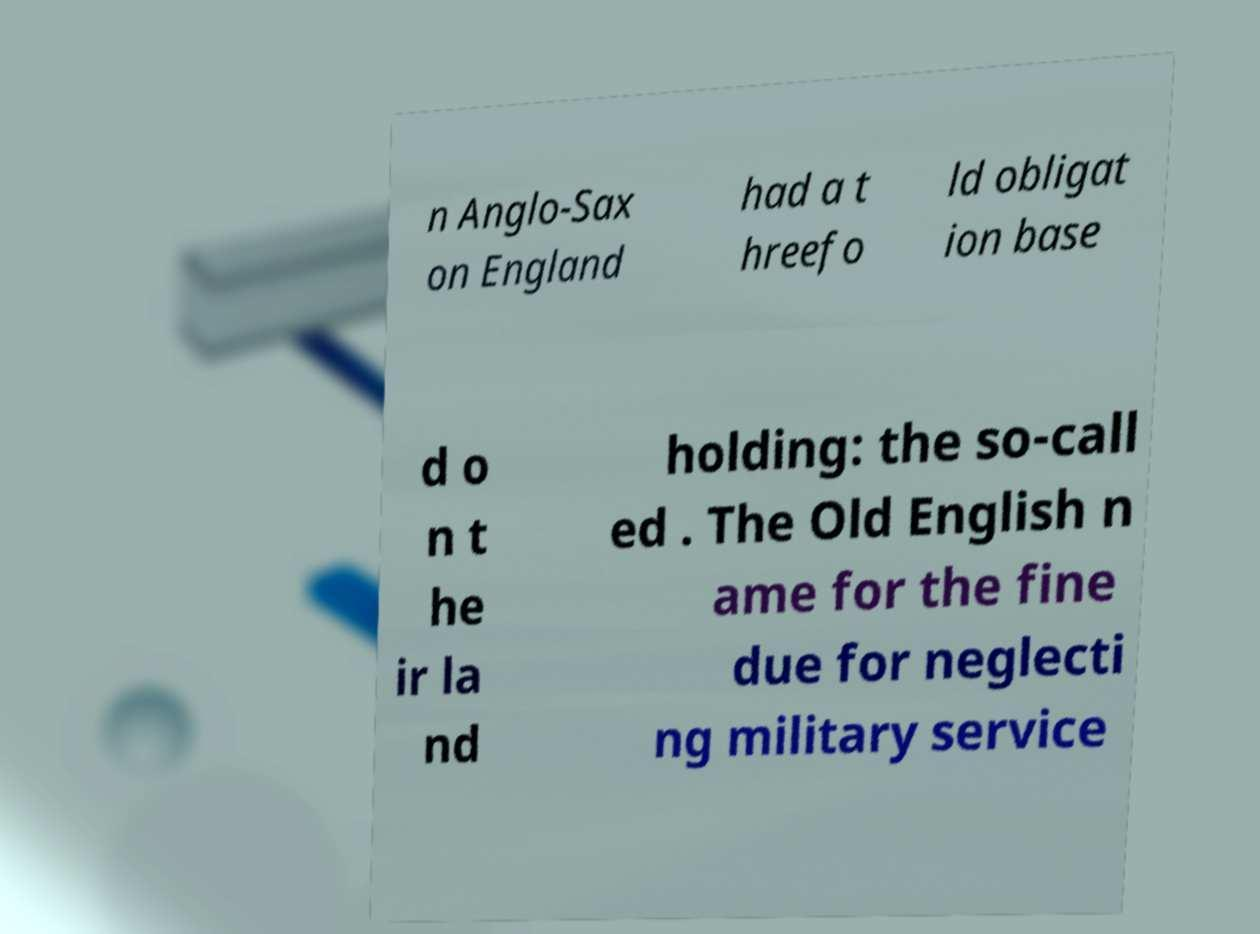Can you read and provide the text displayed in the image?This photo seems to have some interesting text. Can you extract and type it out for me? n Anglo-Sax on England had a t hreefo ld obligat ion base d o n t he ir la nd holding: the so-call ed . The Old English n ame for the fine due for neglecti ng military service 